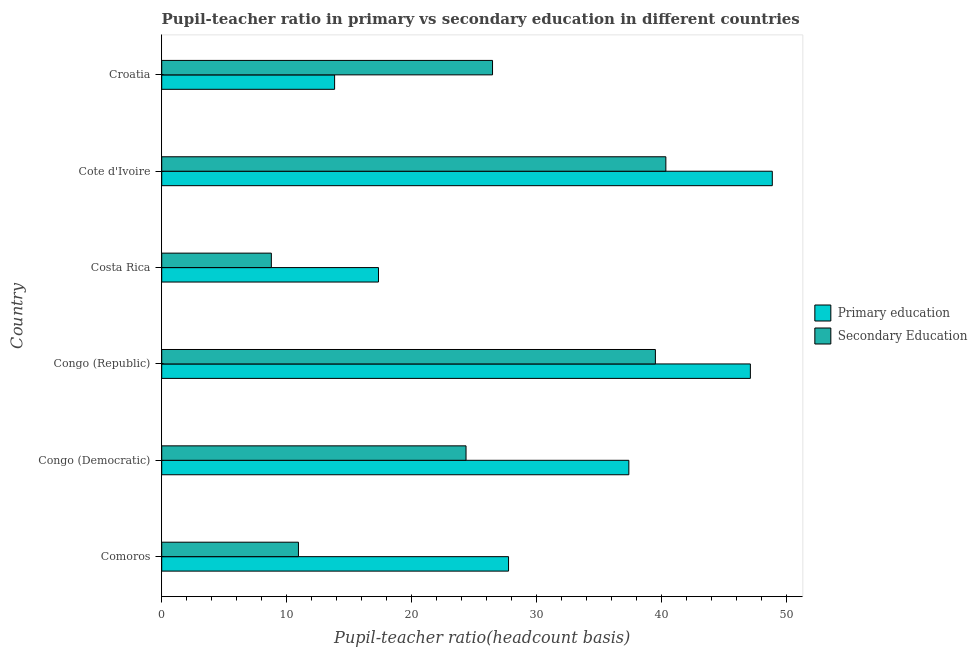How many groups of bars are there?
Make the answer very short. 6. Are the number of bars per tick equal to the number of legend labels?
Keep it short and to the point. Yes. Are the number of bars on each tick of the Y-axis equal?
Offer a very short reply. Yes. How many bars are there on the 1st tick from the bottom?
Provide a succinct answer. 2. What is the label of the 1st group of bars from the top?
Give a very brief answer. Croatia. In how many cases, is the number of bars for a given country not equal to the number of legend labels?
Provide a short and direct response. 0. What is the pupil teacher ratio on secondary education in Comoros?
Ensure brevity in your answer.  10.94. Across all countries, what is the maximum pupil teacher ratio on secondary education?
Give a very brief answer. 40.33. Across all countries, what is the minimum pupil teacher ratio on secondary education?
Give a very brief answer. 8.77. In which country was the pupil-teacher ratio in primary education maximum?
Provide a succinct answer. Cote d'Ivoire. What is the total pupil teacher ratio on secondary education in the graph?
Provide a succinct answer. 150.35. What is the difference between the pupil-teacher ratio in primary education in Congo (Democratic) and that in Croatia?
Keep it short and to the point. 23.54. What is the difference between the pupil teacher ratio on secondary education in Croatia and the pupil-teacher ratio in primary education in Cote d'Ivoire?
Provide a succinct answer. -22.38. What is the average pupil teacher ratio on secondary education per country?
Provide a succinct answer. 25.06. What is the difference between the pupil-teacher ratio in primary education and pupil teacher ratio on secondary education in Congo (Democratic)?
Your answer should be compact. 13.03. In how many countries, is the pupil-teacher ratio in primary education greater than 34 ?
Provide a succinct answer. 3. What is the ratio of the pupil-teacher ratio in primary education in Comoros to that in Congo (Republic)?
Make the answer very short. 0.59. Is the difference between the pupil-teacher ratio in primary education in Congo (Democratic) and Costa Rica greater than the difference between the pupil teacher ratio on secondary education in Congo (Democratic) and Costa Rica?
Your answer should be compact. Yes. What is the difference between the highest and the second highest pupil teacher ratio on secondary education?
Your response must be concise. 0.84. What is the difference between the highest and the lowest pupil teacher ratio on secondary education?
Offer a terse response. 31.56. In how many countries, is the pupil teacher ratio on secondary education greater than the average pupil teacher ratio on secondary education taken over all countries?
Your response must be concise. 3. What does the 2nd bar from the top in Congo (Democratic) represents?
Provide a succinct answer. Primary education. What does the 2nd bar from the bottom in Croatia represents?
Provide a short and direct response. Secondary Education. What is the difference between two consecutive major ticks on the X-axis?
Provide a short and direct response. 10. Does the graph contain any zero values?
Provide a short and direct response. No. Where does the legend appear in the graph?
Your answer should be very brief. Center right. How many legend labels are there?
Give a very brief answer. 2. What is the title of the graph?
Give a very brief answer. Pupil-teacher ratio in primary vs secondary education in different countries. What is the label or title of the X-axis?
Provide a succinct answer. Pupil-teacher ratio(headcount basis). What is the label or title of the Y-axis?
Your response must be concise. Country. What is the Pupil-teacher ratio(headcount basis) in Primary education in Comoros?
Provide a short and direct response. 27.75. What is the Pupil-teacher ratio(headcount basis) of Secondary Education in Comoros?
Offer a terse response. 10.94. What is the Pupil-teacher ratio(headcount basis) of Primary education in Congo (Democratic)?
Ensure brevity in your answer.  37.37. What is the Pupil-teacher ratio(headcount basis) in Secondary Education in Congo (Democratic)?
Provide a short and direct response. 24.35. What is the Pupil-teacher ratio(headcount basis) in Primary education in Congo (Republic)?
Your answer should be compact. 47.09. What is the Pupil-teacher ratio(headcount basis) in Secondary Education in Congo (Republic)?
Your response must be concise. 39.49. What is the Pupil-teacher ratio(headcount basis) in Primary education in Costa Rica?
Offer a very short reply. 17.34. What is the Pupil-teacher ratio(headcount basis) of Secondary Education in Costa Rica?
Provide a succinct answer. 8.77. What is the Pupil-teacher ratio(headcount basis) in Primary education in Cote d'Ivoire?
Provide a succinct answer. 48.85. What is the Pupil-teacher ratio(headcount basis) of Secondary Education in Cote d'Ivoire?
Give a very brief answer. 40.33. What is the Pupil-teacher ratio(headcount basis) of Primary education in Croatia?
Your response must be concise. 13.83. What is the Pupil-teacher ratio(headcount basis) in Secondary Education in Croatia?
Keep it short and to the point. 26.47. Across all countries, what is the maximum Pupil-teacher ratio(headcount basis) in Primary education?
Provide a succinct answer. 48.85. Across all countries, what is the maximum Pupil-teacher ratio(headcount basis) of Secondary Education?
Offer a very short reply. 40.33. Across all countries, what is the minimum Pupil-teacher ratio(headcount basis) in Primary education?
Your response must be concise. 13.83. Across all countries, what is the minimum Pupil-teacher ratio(headcount basis) in Secondary Education?
Provide a short and direct response. 8.77. What is the total Pupil-teacher ratio(headcount basis) of Primary education in the graph?
Ensure brevity in your answer.  192.23. What is the total Pupil-teacher ratio(headcount basis) in Secondary Education in the graph?
Offer a terse response. 150.35. What is the difference between the Pupil-teacher ratio(headcount basis) of Primary education in Comoros and that in Congo (Democratic)?
Keep it short and to the point. -9.62. What is the difference between the Pupil-teacher ratio(headcount basis) of Secondary Education in Comoros and that in Congo (Democratic)?
Keep it short and to the point. -13.41. What is the difference between the Pupil-teacher ratio(headcount basis) of Primary education in Comoros and that in Congo (Republic)?
Provide a short and direct response. -19.35. What is the difference between the Pupil-teacher ratio(headcount basis) in Secondary Education in Comoros and that in Congo (Republic)?
Make the answer very short. -28.55. What is the difference between the Pupil-teacher ratio(headcount basis) in Primary education in Comoros and that in Costa Rica?
Your response must be concise. 10.4. What is the difference between the Pupil-teacher ratio(headcount basis) in Secondary Education in Comoros and that in Costa Rica?
Your response must be concise. 2.17. What is the difference between the Pupil-teacher ratio(headcount basis) of Primary education in Comoros and that in Cote d'Ivoire?
Your response must be concise. -21.1. What is the difference between the Pupil-teacher ratio(headcount basis) in Secondary Education in Comoros and that in Cote d'Ivoire?
Give a very brief answer. -29.39. What is the difference between the Pupil-teacher ratio(headcount basis) in Primary education in Comoros and that in Croatia?
Your answer should be very brief. 13.92. What is the difference between the Pupil-teacher ratio(headcount basis) in Secondary Education in Comoros and that in Croatia?
Offer a very short reply. -15.53. What is the difference between the Pupil-teacher ratio(headcount basis) in Primary education in Congo (Democratic) and that in Congo (Republic)?
Offer a very short reply. -9.72. What is the difference between the Pupil-teacher ratio(headcount basis) of Secondary Education in Congo (Democratic) and that in Congo (Republic)?
Your answer should be very brief. -15.15. What is the difference between the Pupil-teacher ratio(headcount basis) in Primary education in Congo (Democratic) and that in Costa Rica?
Your answer should be compact. 20.03. What is the difference between the Pupil-teacher ratio(headcount basis) in Secondary Education in Congo (Democratic) and that in Costa Rica?
Your answer should be compact. 15.58. What is the difference between the Pupil-teacher ratio(headcount basis) of Primary education in Congo (Democratic) and that in Cote d'Ivoire?
Provide a short and direct response. -11.48. What is the difference between the Pupil-teacher ratio(headcount basis) in Secondary Education in Congo (Democratic) and that in Cote d'Ivoire?
Your answer should be very brief. -15.99. What is the difference between the Pupil-teacher ratio(headcount basis) in Primary education in Congo (Democratic) and that in Croatia?
Provide a succinct answer. 23.54. What is the difference between the Pupil-teacher ratio(headcount basis) in Secondary Education in Congo (Democratic) and that in Croatia?
Keep it short and to the point. -2.12. What is the difference between the Pupil-teacher ratio(headcount basis) in Primary education in Congo (Republic) and that in Costa Rica?
Your response must be concise. 29.75. What is the difference between the Pupil-teacher ratio(headcount basis) in Secondary Education in Congo (Republic) and that in Costa Rica?
Your answer should be very brief. 30.72. What is the difference between the Pupil-teacher ratio(headcount basis) of Primary education in Congo (Republic) and that in Cote d'Ivoire?
Offer a terse response. -1.75. What is the difference between the Pupil-teacher ratio(headcount basis) in Secondary Education in Congo (Republic) and that in Cote d'Ivoire?
Provide a short and direct response. -0.84. What is the difference between the Pupil-teacher ratio(headcount basis) of Primary education in Congo (Republic) and that in Croatia?
Provide a short and direct response. 33.26. What is the difference between the Pupil-teacher ratio(headcount basis) of Secondary Education in Congo (Republic) and that in Croatia?
Provide a succinct answer. 13.03. What is the difference between the Pupil-teacher ratio(headcount basis) of Primary education in Costa Rica and that in Cote d'Ivoire?
Give a very brief answer. -31.5. What is the difference between the Pupil-teacher ratio(headcount basis) of Secondary Education in Costa Rica and that in Cote d'Ivoire?
Provide a succinct answer. -31.56. What is the difference between the Pupil-teacher ratio(headcount basis) of Primary education in Costa Rica and that in Croatia?
Your answer should be compact. 3.51. What is the difference between the Pupil-teacher ratio(headcount basis) in Secondary Education in Costa Rica and that in Croatia?
Make the answer very short. -17.7. What is the difference between the Pupil-teacher ratio(headcount basis) in Primary education in Cote d'Ivoire and that in Croatia?
Your response must be concise. 35.01. What is the difference between the Pupil-teacher ratio(headcount basis) in Secondary Education in Cote d'Ivoire and that in Croatia?
Your response must be concise. 13.87. What is the difference between the Pupil-teacher ratio(headcount basis) in Primary education in Comoros and the Pupil-teacher ratio(headcount basis) in Secondary Education in Congo (Democratic)?
Give a very brief answer. 3.4. What is the difference between the Pupil-teacher ratio(headcount basis) of Primary education in Comoros and the Pupil-teacher ratio(headcount basis) of Secondary Education in Congo (Republic)?
Offer a very short reply. -11.75. What is the difference between the Pupil-teacher ratio(headcount basis) of Primary education in Comoros and the Pupil-teacher ratio(headcount basis) of Secondary Education in Costa Rica?
Your answer should be very brief. 18.98. What is the difference between the Pupil-teacher ratio(headcount basis) of Primary education in Comoros and the Pupil-teacher ratio(headcount basis) of Secondary Education in Cote d'Ivoire?
Your response must be concise. -12.58. What is the difference between the Pupil-teacher ratio(headcount basis) in Primary education in Comoros and the Pupil-teacher ratio(headcount basis) in Secondary Education in Croatia?
Your answer should be very brief. 1.28. What is the difference between the Pupil-teacher ratio(headcount basis) in Primary education in Congo (Democratic) and the Pupil-teacher ratio(headcount basis) in Secondary Education in Congo (Republic)?
Your answer should be very brief. -2.12. What is the difference between the Pupil-teacher ratio(headcount basis) in Primary education in Congo (Democratic) and the Pupil-teacher ratio(headcount basis) in Secondary Education in Costa Rica?
Make the answer very short. 28.6. What is the difference between the Pupil-teacher ratio(headcount basis) of Primary education in Congo (Democratic) and the Pupil-teacher ratio(headcount basis) of Secondary Education in Cote d'Ivoire?
Your response must be concise. -2.96. What is the difference between the Pupil-teacher ratio(headcount basis) of Primary education in Congo (Democratic) and the Pupil-teacher ratio(headcount basis) of Secondary Education in Croatia?
Ensure brevity in your answer.  10.91. What is the difference between the Pupil-teacher ratio(headcount basis) in Primary education in Congo (Republic) and the Pupil-teacher ratio(headcount basis) in Secondary Education in Costa Rica?
Give a very brief answer. 38.32. What is the difference between the Pupil-teacher ratio(headcount basis) of Primary education in Congo (Republic) and the Pupil-teacher ratio(headcount basis) of Secondary Education in Cote d'Ivoire?
Offer a very short reply. 6.76. What is the difference between the Pupil-teacher ratio(headcount basis) in Primary education in Congo (Republic) and the Pupil-teacher ratio(headcount basis) in Secondary Education in Croatia?
Offer a very short reply. 20.63. What is the difference between the Pupil-teacher ratio(headcount basis) of Primary education in Costa Rica and the Pupil-teacher ratio(headcount basis) of Secondary Education in Cote d'Ivoire?
Keep it short and to the point. -22.99. What is the difference between the Pupil-teacher ratio(headcount basis) in Primary education in Costa Rica and the Pupil-teacher ratio(headcount basis) in Secondary Education in Croatia?
Keep it short and to the point. -9.12. What is the difference between the Pupil-teacher ratio(headcount basis) in Primary education in Cote d'Ivoire and the Pupil-teacher ratio(headcount basis) in Secondary Education in Croatia?
Provide a short and direct response. 22.38. What is the average Pupil-teacher ratio(headcount basis) in Primary education per country?
Your response must be concise. 32.04. What is the average Pupil-teacher ratio(headcount basis) in Secondary Education per country?
Your response must be concise. 25.06. What is the difference between the Pupil-teacher ratio(headcount basis) in Primary education and Pupil-teacher ratio(headcount basis) in Secondary Education in Comoros?
Your answer should be compact. 16.81. What is the difference between the Pupil-teacher ratio(headcount basis) in Primary education and Pupil-teacher ratio(headcount basis) in Secondary Education in Congo (Democratic)?
Ensure brevity in your answer.  13.03. What is the difference between the Pupil-teacher ratio(headcount basis) of Primary education and Pupil-teacher ratio(headcount basis) of Secondary Education in Congo (Republic)?
Your response must be concise. 7.6. What is the difference between the Pupil-teacher ratio(headcount basis) in Primary education and Pupil-teacher ratio(headcount basis) in Secondary Education in Costa Rica?
Your answer should be very brief. 8.57. What is the difference between the Pupil-teacher ratio(headcount basis) in Primary education and Pupil-teacher ratio(headcount basis) in Secondary Education in Cote d'Ivoire?
Your response must be concise. 8.51. What is the difference between the Pupil-teacher ratio(headcount basis) of Primary education and Pupil-teacher ratio(headcount basis) of Secondary Education in Croatia?
Offer a terse response. -12.63. What is the ratio of the Pupil-teacher ratio(headcount basis) in Primary education in Comoros to that in Congo (Democratic)?
Provide a succinct answer. 0.74. What is the ratio of the Pupil-teacher ratio(headcount basis) of Secondary Education in Comoros to that in Congo (Democratic)?
Offer a very short reply. 0.45. What is the ratio of the Pupil-teacher ratio(headcount basis) in Primary education in Comoros to that in Congo (Republic)?
Your answer should be very brief. 0.59. What is the ratio of the Pupil-teacher ratio(headcount basis) of Secondary Education in Comoros to that in Congo (Republic)?
Ensure brevity in your answer.  0.28. What is the ratio of the Pupil-teacher ratio(headcount basis) in Secondary Education in Comoros to that in Costa Rica?
Your answer should be very brief. 1.25. What is the ratio of the Pupil-teacher ratio(headcount basis) of Primary education in Comoros to that in Cote d'Ivoire?
Provide a succinct answer. 0.57. What is the ratio of the Pupil-teacher ratio(headcount basis) in Secondary Education in Comoros to that in Cote d'Ivoire?
Give a very brief answer. 0.27. What is the ratio of the Pupil-teacher ratio(headcount basis) of Primary education in Comoros to that in Croatia?
Offer a very short reply. 2.01. What is the ratio of the Pupil-teacher ratio(headcount basis) in Secondary Education in Comoros to that in Croatia?
Provide a succinct answer. 0.41. What is the ratio of the Pupil-teacher ratio(headcount basis) of Primary education in Congo (Democratic) to that in Congo (Republic)?
Keep it short and to the point. 0.79. What is the ratio of the Pupil-teacher ratio(headcount basis) in Secondary Education in Congo (Democratic) to that in Congo (Republic)?
Provide a short and direct response. 0.62. What is the ratio of the Pupil-teacher ratio(headcount basis) in Primary education in Congo (Democratic) to that in Costa Rica?
Ensure brevity in your answer.  2.15. What is the ratio of the Pupil-teacher ratio(headcount basis) in Secondary Education in Congo (Democratic) to that in Costa Rica?
Your answer should be very brief. 2.78. What is the ratio of the Pupil-teacher ratio(headcount basis) of Primary education in Congo (Democratic) to that in Cote d'Ivoire?
Offer a very short reply. 0.77. What is the ratio of the Pupil-teacher ratio(headcount basis) of Secondary Education in Congo (Democratic) to that in Cote d'Ivoire?
Provide a succinct answer. 0.6. What is the ratio of the Pupil-teacher ratio(headcount basis) of Primary education in Congo (Democratic) to that in Croatia?
Your answer should be very brief. 2.7. What is the ratio of the Pupil-teacher ratio(headcount basis) of Secondary Education in Congo (Democratic) to that in Croatia?
Keep it short and to the point. 0.92. What is the ratio of the Pupil-teacher ratio(headcount basis) of Primary education in Congo (Republic) to that in Costa Rica?
Your answer should be very brief. 2.72. What is the ratio of the Pupil-teacher ratio(headcount basis) of Secondary Education in Congo (Republic) to that in Costa Rica?
Provide a short and direct response. 4.5. What is the ratio of the Pupil-teacher ratio(headcount basis) in Primary education in Congo (Republic) to that in Cote d'Ivoire?
Offer a very short reply. 0.96. What is the ratio of the Pupil-teacher ratio(headcount basis) in Secondary Education in Congo (Republic) to that in Cote d'Ivoire?
Your answer should be compact. 0.98. What is the ratio of the Pupil-teacher ratio(headcount basis) of Primary education in Congo (Republic) to that in Croatia?
Your answer should be very brief. 3.4. What is the ratio of the Pupil-teacher ratio(headcount basis) in Secondary Education in Congo (Republic) to that in Croatia?
Provide a succinct answer. 1.49. What is the ratio of the Pupil-teacher ratio(headcount basis) in Primary education in Costa Rica to that in Cote d'Ivoire?
Provide a succinct answer. 0.35. What is the ratio of the Pupil-teacher ratio(headcount basis) in Secondary Education in Costa Rica to that in Cote d'Ivoire?
Provide a short and direct response. 0.22. What is the ratio of the Pupil-teacher ratio(headcount basis) of Primary education in Costa Rica to that in Croatia?
Provide a short and direct response. 1.25. What is the ratio of the Pupil-teacher ratio(headcount basis) in Secondary Education in Costa Rica to that in Croatia?
Give a very brief answer. 0.33. What is the ratio of the Pupil-teacher ratio(headcount basis) in Primary education in Cote d'Ivoire to that in Croatia?
Provide a short and direct response. 3.53. What is the ratio of the Pupil-teacher ratio(headcount basis) of Secondary Education in Cote d'Ivoire to that in Croatia?
Keep it short and to the point. 1.52. What is the difference between the highest and the second highest Pupil-teacher ratio(headcount basis) in Primary education?
Your answer should be compact. 1.75. What is the difference between the highest and the second highest Pupil-teacher ratio(headcount basis) in Secondary Education?
Make the answer very short. 0.84. What is the difference between the highest and the lowest Pupil-teacher ratio(headcount basis) of Primary education?
Offer a terse response. 35.01. What is the difference between the highest and the lowest Pupil-teacher ratio(headcount basis) in Secondary Education?
Provide a succinct answer. 31.56. 